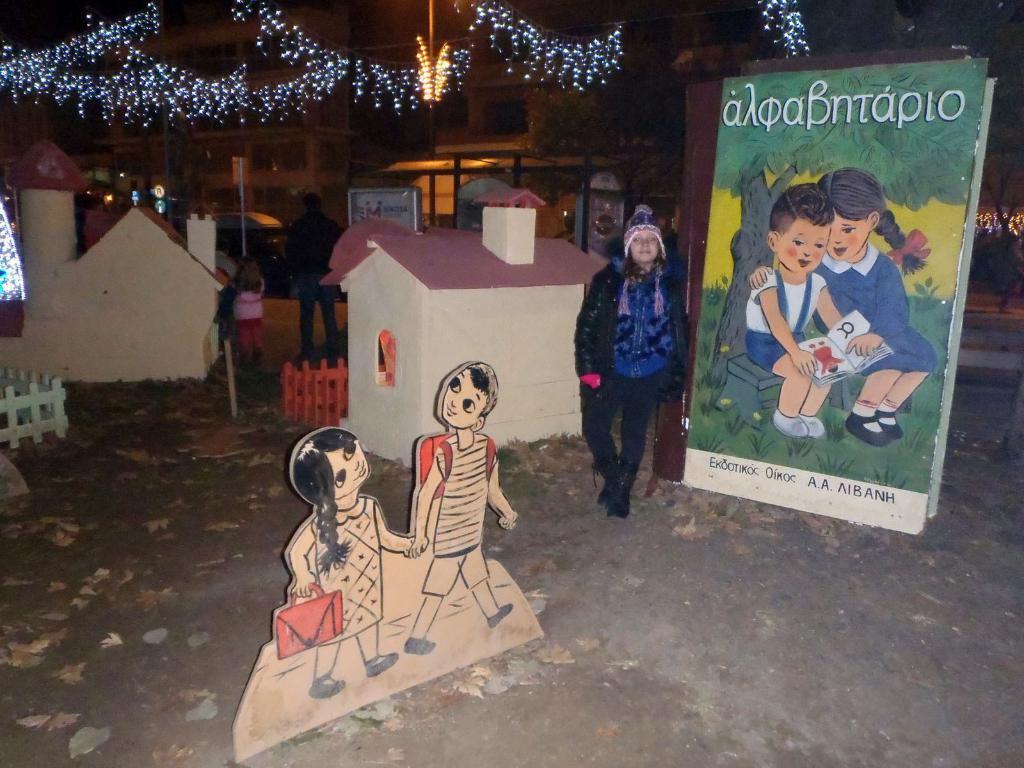Please provide a concise description of this image. In this image I can see boards, posters, houses, fence, group of people on the road, vehicles, light poles and decorating lights on buildings. This image is taken may be during night. 